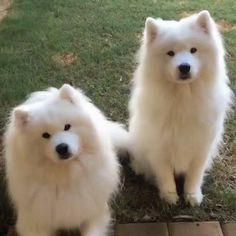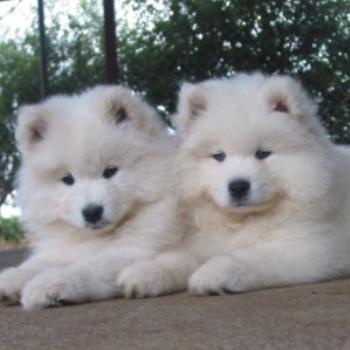The first image is the image on the left, the second image is the image on the right. Considering the images on both sides, is "The dog's tongue is sticking out in at least one of the images." valid? Answer yes or no. No. The first image is the image on the left, the second image is the image on the right. Considering the images on both sides, is "An image includes a reclining white dog with both eyes shut." valid? Answer yes or no. No. 